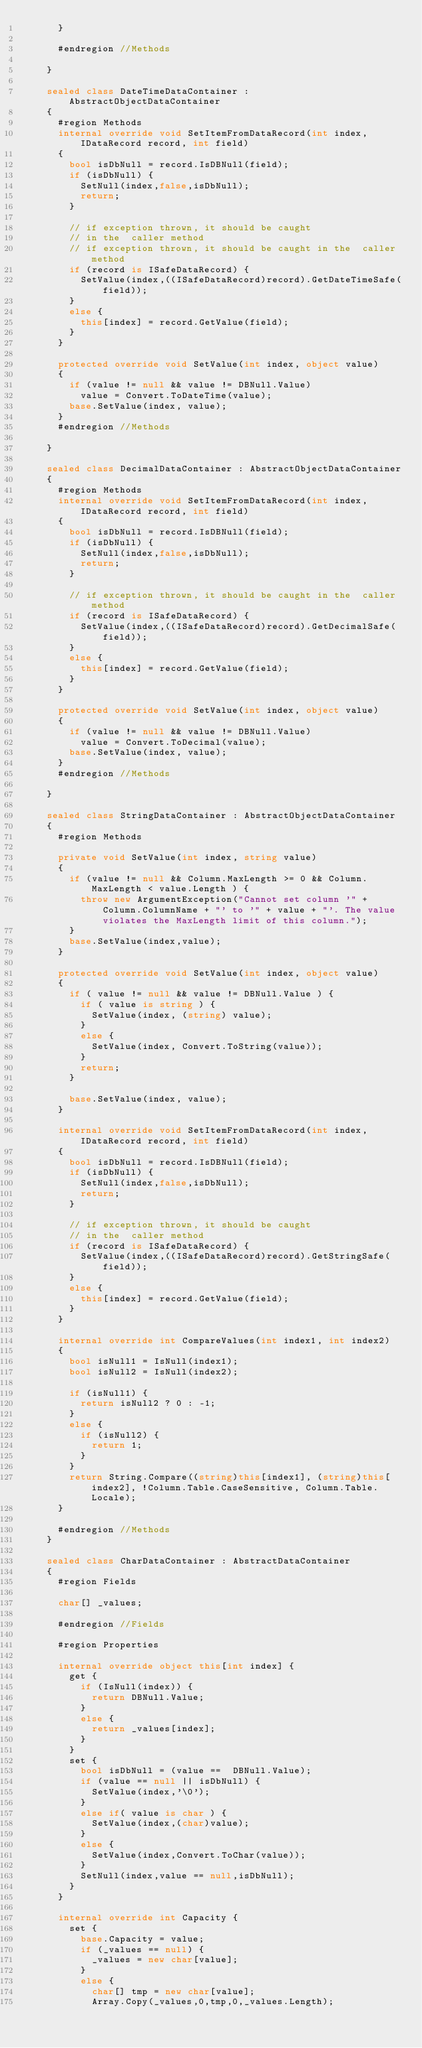Convert code to text. <code><loc_0><loc_0><loc_500><loc_500><_C#_>			}

			#endregion //Methods
	 
		}

		sealed class DateTimeDataContainer : AbstractObjectDataContainer
		{
			#region Methods
			internal override void SetItemFromDataRecord(int index, IDataRecord record, int field)
			{
				bool isDbNull = record.IsDBNull(field);
				if (isDbNull) {
					SetNull(index,false,isDbNull);
					return;
				}

				// if exception thrown, it should be caught 
				// in the  caller method
				// if exception thrown, it should be caught in the  caller method
				if (record is ISafeDataRecord) {
					SetValue(index,((ISafeDataRecord)record).GetDateTimeSafe(field));
				}
				else {
					this[index] = record.GetValue(field);
				}
			}

			protected override void SetValue(int index, object value)
			{
				if (value != null && value != DBNull.Value)
					value = Convert.ToDateTime(value);
				base.SetValue(index, value);
			}
			#endregion //Methods
	 
		}

		sealed class DecimalDataContainer : AbstractObjectDataContainer
		{
			#region Methods
			internal override void SetItemFromDataRecord(int index, IDataRecord record, int field)
			{
				bool isDbNull = record.IsDBNull(field);
				if (isDbNull) {
					SetNull(index,false,isDbNull);
					return;
				}

				// if exception thrown, it should be caught in the  caller method
				if (record is ISafeDataRecord) {
					SetValue(index,((ISafeDataRecord)record).GetDecimalSafe(field));
				}
				else {
					this[index] = record.GetValue(field);
				}
			}

			protected override void SetValue(int index, object value)
			{
				if (value != null && value != DBNull.Value)
					value = Convert.ToDecimal(value);
				base.SetValue(index, value);
			}
			#endregion //Methods
	 
		}

		sealed class StringDataContainer : AbstractObjectDataContainer
		{
			#region Methods

			private void SetValue(int index, string value)
			{
				if (value != null && Column.MaxLength >= 0 && Column.MaxLength < value.Length ) {
					throw new ArgumentException("Cannot set column '" + Column.ColumnName + "' to '" + value + "'. The value violates the MaxLength limit of this column.");
				}
				base.SetValue(index,value);
			}
			
			protected override void SetValue(int index, object value)
			{
				if ( value != null && value != DBNull.Value ) {
					if ( value is string ) {
						SetValue(index, (string) value);
					}
					else {
						SetValue(index, Convert.ToString(value));
					}
					return;
				}

				base.SetValue(index, value);
			}

			internal override void SetItemFromDataRecord(int index, IDataRecord record, int field)
			{
				bool isDbNull = record.IsDBNull(field);
				if (isDbNull) {
					SetNull(index,false,isDbNull);
					return;
				}

				// if exception thrown, it should be caught 
				// in the  caller method
				if (record is ISafeDataRecord) {
					SetValue(index,((ISafeDataRecord)record).GetStringSafe(field));
				}
				else {
					this[index] = record.GetValue(field);
				}
			}

			internal override int CompareValues(int index1, int index2)
			{
				bool isNull1 = IsNull(index1);
				bool isNull2 = IsNull(index2);

				if (isNull1) {
					return isNull2 ? 0 : -1;
				}
				else {
					if (isNull2) {
						return 1;
					}
				}
				return String.Compare((string)this[index1], (string)this[index2], !Column.Table.CaseSensitive, Column.Table.Locale);
			}

			#endregion //Methods 
		}

		sealed class CharDataContainer : AbstractDataContainer
		{
			#region Fields
		
			char[] _values;

			#endregion //Fields

			#region Properties

			internal override object this[int index] {
				get {
					if (IsNull(index)) {
						return DBNull.Value;
					}
					else {
						return _values[index];
					}
				}
				set {
					bool isDbNull = (value ==  DBNull.Value);
					if (value == null || isDbNull) {
						SetValue(index,'\0');
					}
					else if( value is char ) {
						SetValue(index,(char)value);
					}
					else {
						SetValue(index,Convert.ToChar(value));
					}
					SetNull(index,value == null,isDbNull);
				}
			}

			internal override int Capacity {
				set {
					base.Capacity = value;
					if (_values == null) {
						_values = new char[value];
					}
					else {
						char[] tmp = new char[value];
						Array.Copy(_values,0,tmp,0,_values.Length);</code> 